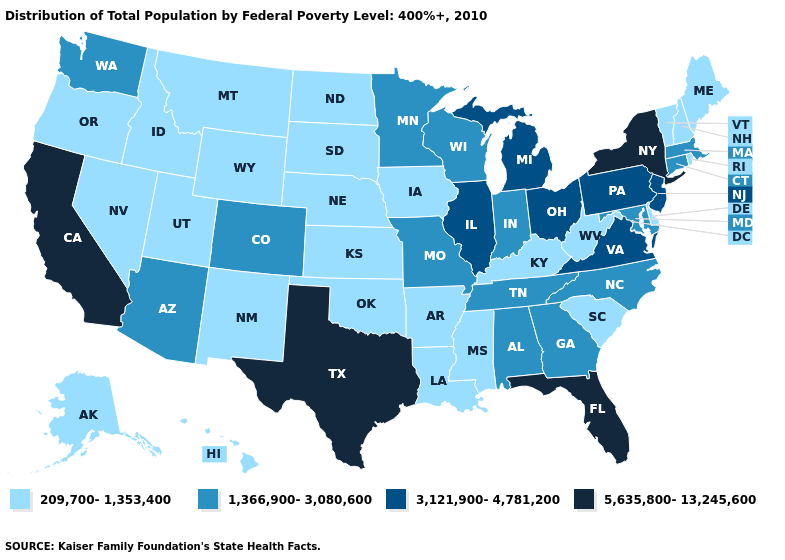What is the highest value in the MidWest ?
Write a very short answer. 3,121,900-4,781,200. Which states hav the highest value in the MidWest?
Quick response, please. Illinois, Michigan, Ohio. Name the states that have a value in the range 5,635,800-13,245,600?
Be succinct. California, Florida, New York, Texas. Among the states that border Pennsylvania , which have the highest value?
Write a very short answer. New York. What is the value of Idaho?
Answer briefly. 209,700-1,353,400. How many symbols are there in the legend?
Concise answer only. 4. Among the states that border Nebraska , does South Dakota have the lowest value?
Give a very brief answer. Yes. Name the states that have a value in the range 3,121,900-4,781,200?
Answer briefly. Illinois, Michigan, New Jersey, Ohio, Pennsylvania, Virginia. What is the lowest value in states that border Kentucky?
Answer briefly. 209,700-1,353,400. Name the states that have a value in the range 3,121,900-4,781,200?
Quick response, please. Illinois, Michigan, New Jersey, Ohio, Pennsylvania, Virginia. What is the value of Utah?
Write a very short answer. 209,700-1,353,400. Does Virginia have a higher value than West Virginia?
Answer briefly. Yes. What is the highest value in the South ?
Give a very brief answer. 5,635,800-13,245,600. Name the states that have a value in the range 209,700-1,353,400?
Write a very short answer. Alaska, Arkansas, Delaware, Hawaii, Idaho, Iowa, Kansas, Kentucky, Louisiana, Maine, Mississippi, Montana, Nebraska, Nevada, New Hampshire, New Mexico, North Dakota, Oklahoma, Oregon, Rhode Island, South Carolina, South Dakota, Utah, Vermont, West Virginia, Wyoming. 